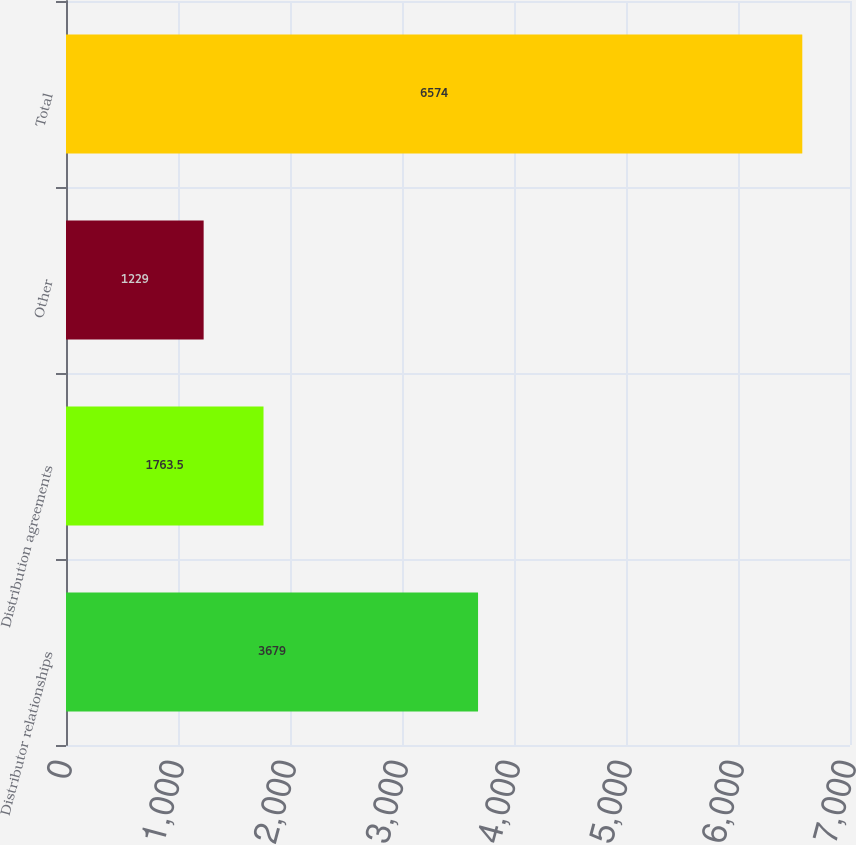Convert chart to OTSL. <chart><loc_0><loc_0><loc_500><loc_500><bar_chart><fcel>Distributor relationships<fcel>Distribution agreements<fcel>Other<fcel>Total<nl><fcel>3679<fcel>1763.5<fcel>1229<fcel>6574<nl></chart> 